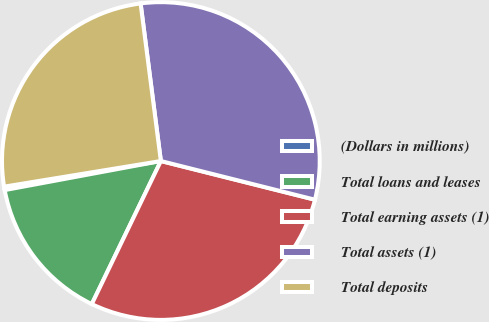<chart> <loc_0><loc_0><loc_500><loc_500><pie_chart><fcel>(Dollars in millions)<fcel>Total loans and leases<fcel>Total earning assets (1)<fcel>Total assets (1)<fcel>Total deposits<nl><fcel>0.35%<fcel>14.91%<fcel>28.24%<fcel>30.95%<fcel>25.54%<nl></chart> 